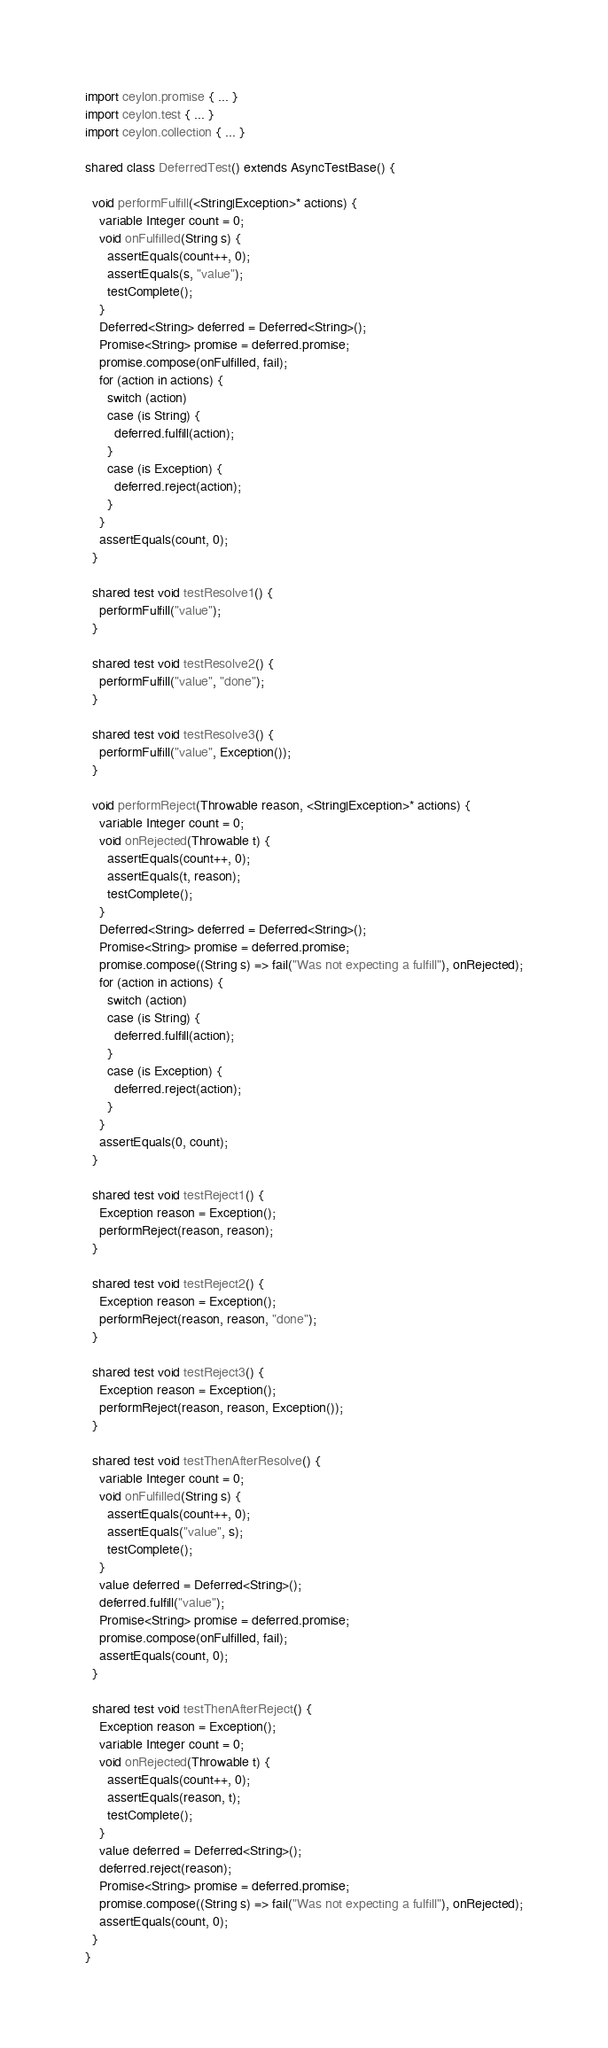<code> <loc_0><loc_0><loc_500><loc_500><_Ceylon_>import ceylon.promise { ... }
import ceylon.test { ... }
import ceylon.collection { ... }

shared class DeferredTest() extends AsyncTestBase() {
  
  void performFulfill(<String|Exception>* actions) {
    variable Integer count = 0;
    void onFulfilled(String s) {
      assertEquals(count++, 0);
      assertEquals(s, "value");
      testComplete();
    }
    Deferred<String> deferred = Deferred<String>();
    Promise<String> promise = deferred.promise;
    promise.compose(onFulfilled, fail);
    for (action in actions) {
      switch (action)
      case (is String) {
        deferred.fulfill(action);
      }
      case (is Exception) {
        deferred.reject(action);
      }
    }
    assertEquals(count, 0);
  }

  shared test void testResolve1() {
    performFulfill("value");
  }
  
  shared test void testResolve2() {
    performFulfill("value", "done");
  }
  
  shared test void testResolve3() {
    performFulfill("value", Exception());
  }

  void performReject(Throwable reason, <String|Exception>* actions) {
    variable Integer count = 0;
    void onRejected(Throwable t) {
      assertEquals(count++, 0);
      assertEquals(t, reason);
      testComplete();
    }
    Deferred<String> deferred = Deferred<String>();
    Promise<String> promise = deferred.promise;
    promise.compose((String s) => fail("Was not expecting a fulfill"), onRejected);
    for (action in actions) {
      switch (action)
      case (is String) {
        deferred.fulfill(action);
      }
      case (is Exception) {
        deferred.reject(action);
      }
    }
    assertEquals(0, count);
  }

  shared test void testReject1() {
    Exception reason = Exception();
    performReject(reason, reason);
  }

  shared test void testReject2() {
    Exception reason = Exception();
    performReject(reason, reason, "done");
  }

  shared test void testReject3() {
    Exception reason = Exception();
    performReject(reason, reason, Exception());
  }

  shared test void testThenAfterResolve() {
    variable Integer count = 0;
    void onFulfilled(String s) {
      assertEquals(count++, 0);
      assertEquals("value", s);
      testComplete();
    }
    value deferred = Deferred<String>();
    deferred.fulfill("value");
    Promise<String> promise = deferred.promise;
    promise.compose(onFulfilled, fail);
    assertEquals(count, 0);
  }

  shared test void testThenAfterReject() {
    Exception reason = Exception();
    variable Integer count = 0;
    void onRejected(Throwable t) {
      assertEquals(count++, 0);
      assertEquals(reason, t);
      testComplete();
    }    
    value deferred = Deferred<String>();
    deferred.reject(reason);
    Promise<String> promise = deferred.promise;
    promise.compose((String s) => fail("Was not expecting a fulfill"), onRejected);
    assertEquals(count, 0);
  }
}
</code> 